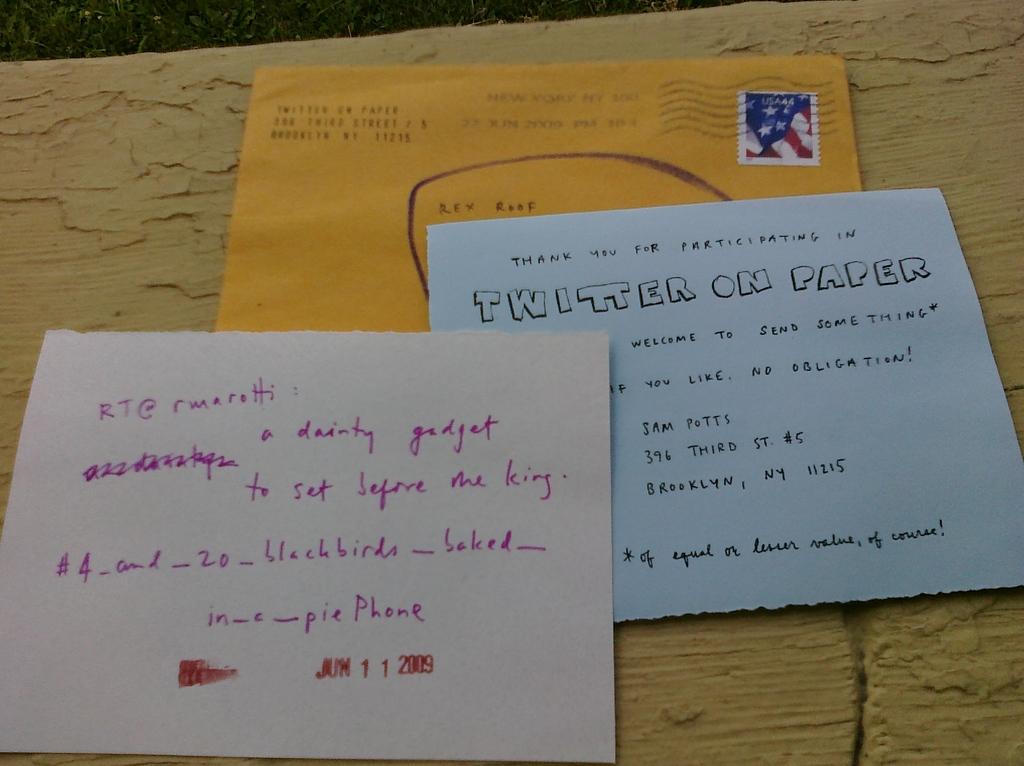Who is the envelope addressed to?
Your answer should be compact. Rex roof. What does the note on the right say thank you for?
Keep it short and to the point. Participating. 